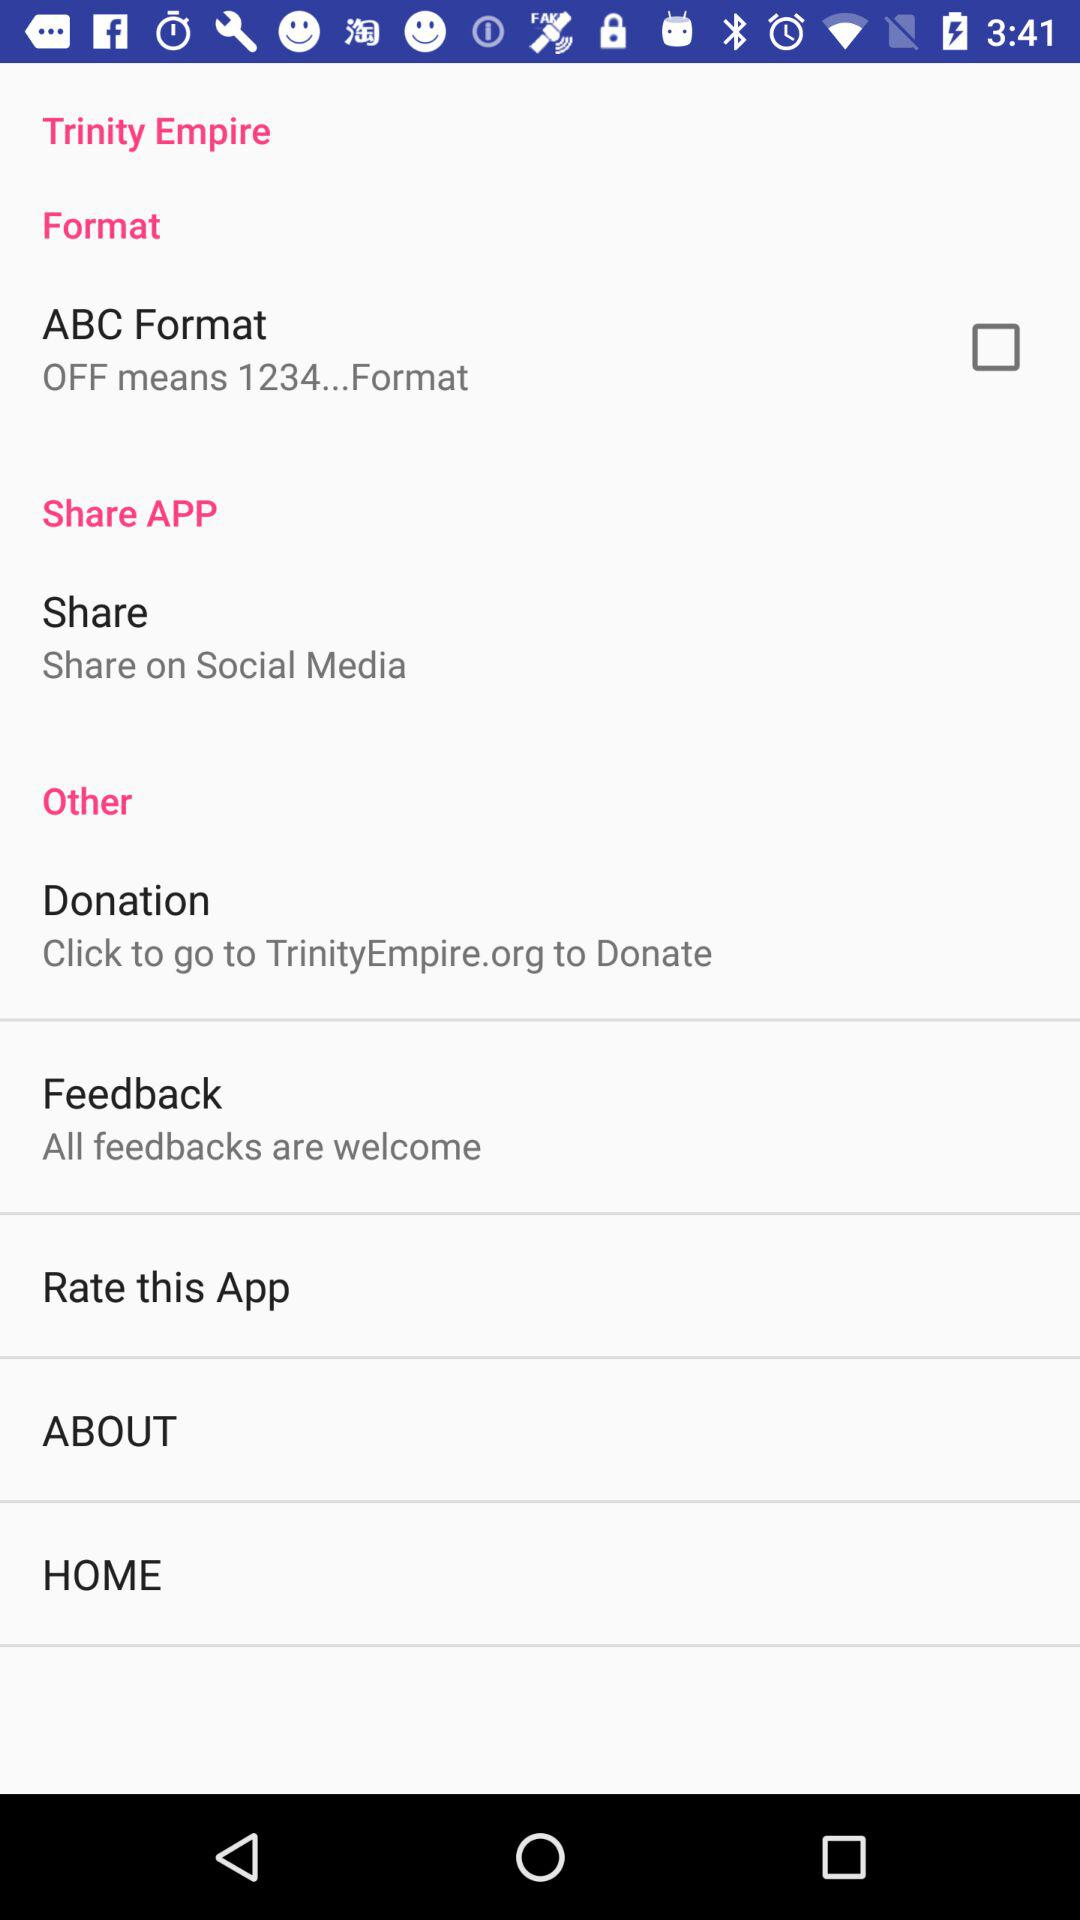How can the user donate? The user can donate on TrinityEmpire.org. 